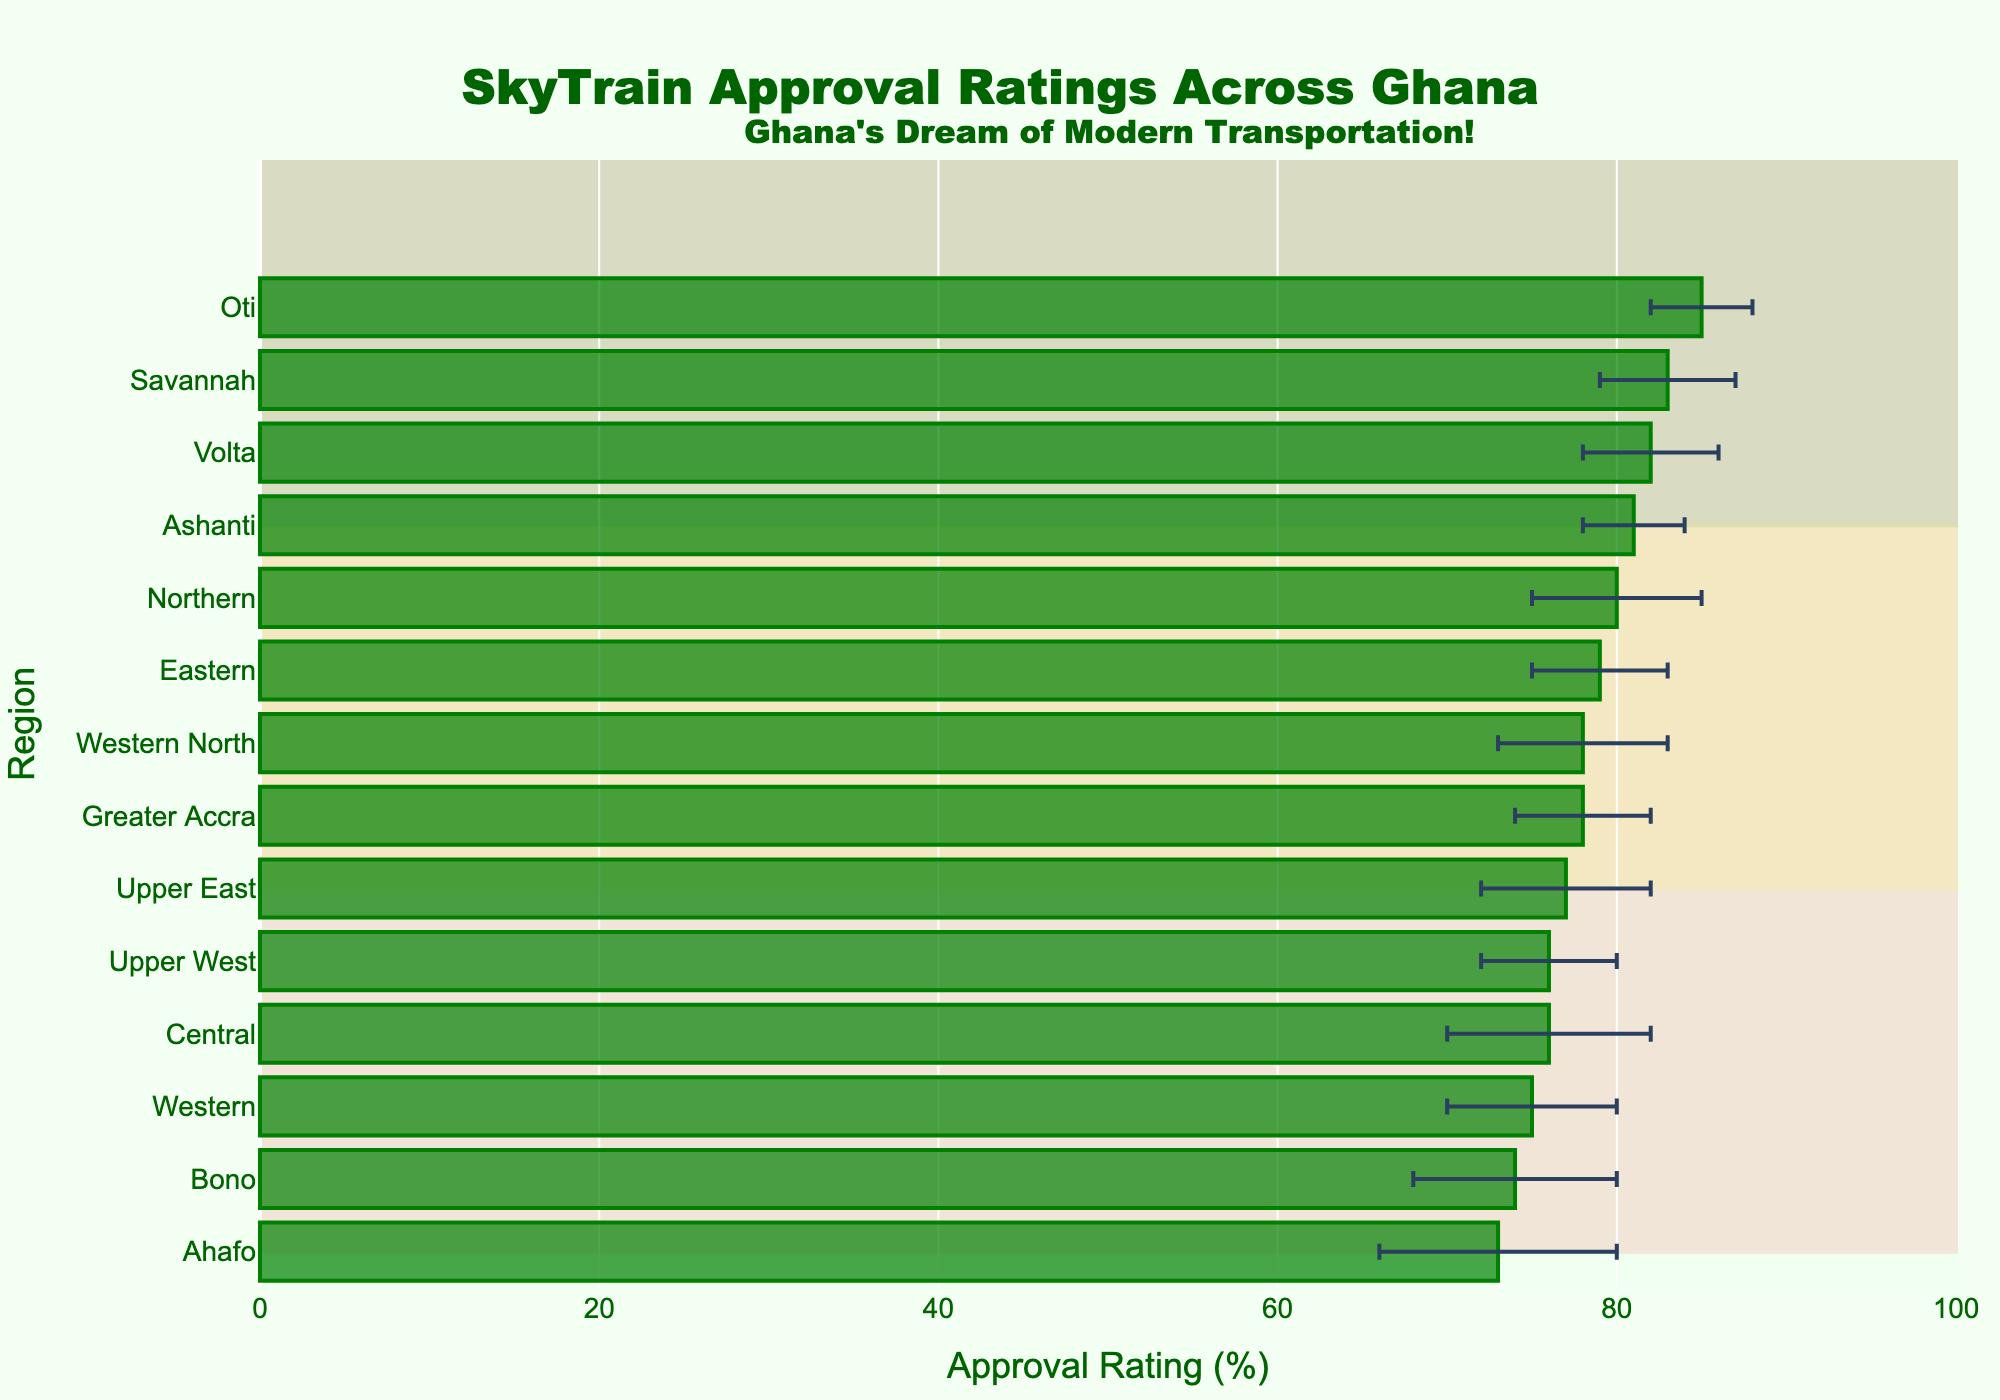What's the highest approval rating for the SkyTrain project? Observing the bar heights and checking the approval ratings on the x-axis, the highest approval rating is 85% for the Oti region.
Answer: 85% Which region has the lowest approval rating for the SkyTrain project? By comparing the bar lengths on the x-axis, the shortest bar, indicating the lowest approval rating, belongs to the Ahafo region with a rating of 73%.
Answer: Ahafo What is the difference in approval ratings between the Oti and Bono regions? The approval rating for Oti is 85% and for Bono is 74%. The difference is calculated as 85% - 74% = 11%.
Answer: 11% What is the average approval rating across all regions? Adding the approval ratings across all regions (78 + 81 + 75 + 82 + 76 + 80 + 79 + 77 + 76 + 74 + 73 + 85 + 83 + 78) gives 1117. Dividing by the number of regions (14) results in an average rating of 79.79%.
Answer: 79.79% Which two regions have the same range of error bars, and what is that range? By comparing the error bars visually, the Greater Accra and the Eastern regions both have an error range of +/- 4%.
Answer: Greater Accra and Eastern, 4% Which region has the smallest standard deviation, and what is the corresponding approval rating? Observing the error bars, Oti has the smallest standard deviation of 3%. The corresponding approval rating for Oti is 85%.
Answer: Oti, 85% Is the approval rating for the Northern region higher than the average approval rating? The approval rating for the Northern region is 80%. The average approval rating across all regions is 79.79%. Since 80% > 79.79%, the Northern region's approval rating is higher than the average.
Answer: Yes How many regions have approval ratings above 80%? Counting the regions with approval ratings over 80%, we find the following regions fit: Ashanti (81%), Volta (82%), Oti (85%), and Savannah (83%). This results in 4 regions.
Answer: 4 What is the total range of approval ratings for the SkyTrain project across all regions? The highest approval rating is 85% (Oti) and the lowest is 73% (Ahafo). The total range is 85% - 73% = 12%.
Answer: 12% 